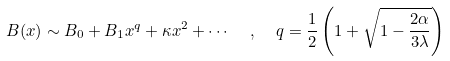<formula> <loc_0><loc_0><loc_500><loc_500>B ( x ) \sim B _ { 0 } + B _ { 1 } x ^ { q } + \kappa x ^ { 2 } + \cdots \ \ , \ \ q = \frac { 1 } { 2 } \left ( 1 + \sqrt { 1 - \frac { 2 \alpha } { 3 \lambda } } \right )</formula> 